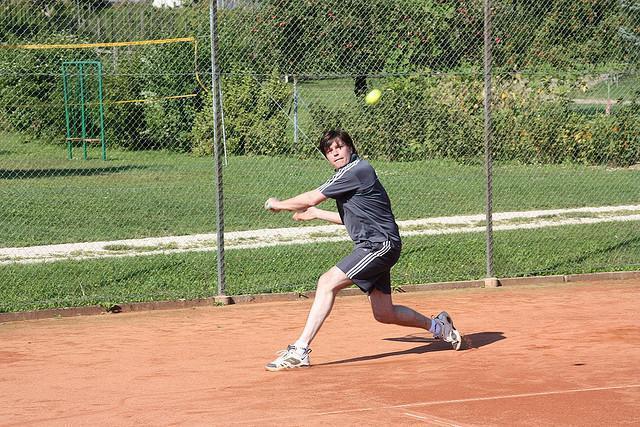How many black dog in the image?
Give a very brief answer. 0. 